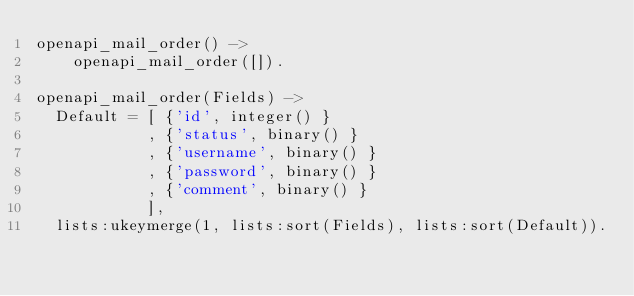Convert code to text. <code><loc_0><loc_0><loc_500><loc_500><_Erlang_>openapi_mail_order() ->
    openapi_mail_order([]).

openapi_mail_order(Fields) ->
  Default = [ {'id', integer() }
            , {'status', binary() }
            , {'username', binary() }
            , {'password', binary() }
            , {'comment', binary() }
            ],
  lists:ukeymerge(1, lists:sort(Fields), lists:sort(Default)).

</code> 